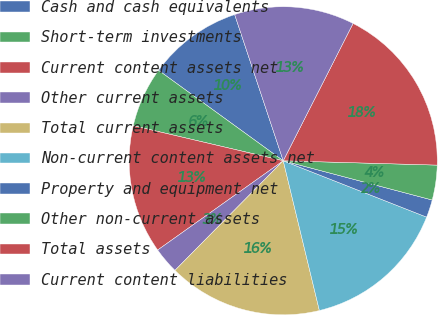<chart> <loc_0><loc_0><loc_500><loc_500><pie_chart><fcel>Cash and cash equivalents<fcel>Short-term investments<fcel>Current content assets net<fcel>Other current assets<fcel>Total current assets<fcel>Non-current content assets net<fcel>Property and equipment net<fcel>Other non-current assets<fcel>Total assets<fcel>Current content liabilities<nl><fcel>9.91%<fcel>6.33%<fcel>13.49%<fcel>2.76%<fcel>16.17%<fcel>15.27%<fcel>1.86%<fcel>3.65%<fcel>17.96%<fcel>12.59%<nl></chart> 